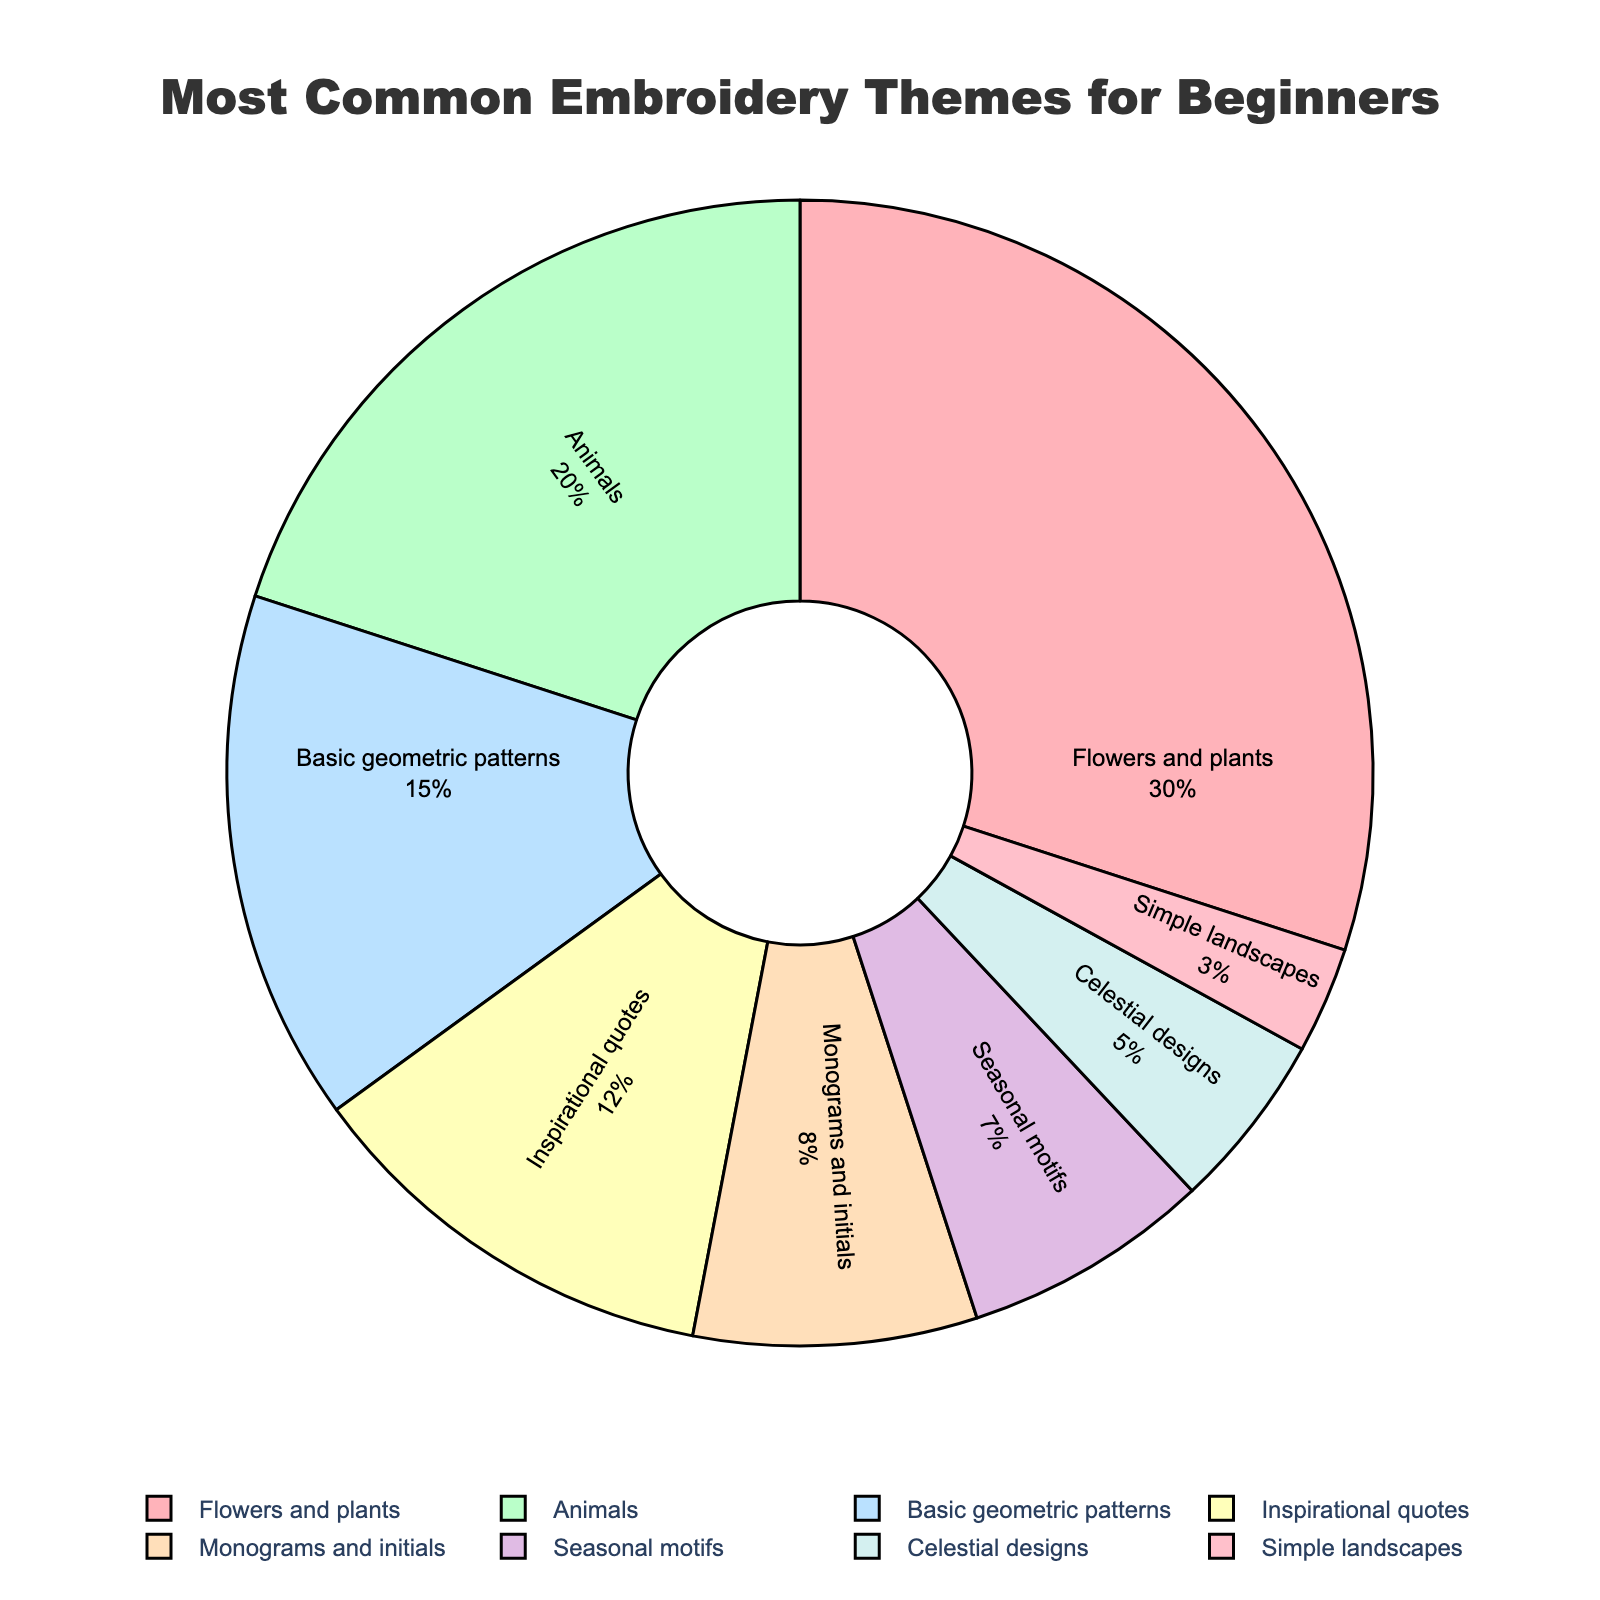Which theme is the most popular among beginners according to the pie chart? The largest segment in the pie chart represents the theme "Flowers and plants," which takes up 30% of the total.
Answer: Flowers and plants How do the percentages of animals and basic geometric patterns compare? The segment for animals is 20%, and the segment for basic geometric patterns is 15%. Comparing these values, animals have a higher percentage than basic geometric patterns.
Answer: Animals What is the combined percentage of inspirational quotes, monograms and initials, and seasonal motifs? Inspirational quotes: 12%, Monograms and initials: 8%, Seasonal motifs: 7%. Adding these together, 12% + 8% + 7% = 27%.
Answer: 27% Which theme has the smallest representation in the pie chart? The smallest segment in the pie chart is for "Simple landscapes," which has a percentage of 3%.
Answer: Simple landscapes How much larger in percentage is the representation of flowers and plants compared to celestial designs? The flowers and plants segment has 30%, and celestial designs have 5%. The difference is 30% - 5% = 25%.
Answer: 25% If you were to combine the percentages for simple landscapes and seasonal motifs, would this new segment be larger than the monograms and initials segment? Simple landscapes: 3%, Seasonal motifs: 7%. Combined percentage is 3% + 7% = 10%. Monograms and initials is 8%. 10% is larger than 8%.
Answer: Yes What percentage of embroidery themes falls under the "miscellaneous" category, grouping themes with less than 10% representation together (seasonal motifs, celestial designs, simple landscapes)? Seasonal motifs: 7%, Celestial designs: 5%, Simple landscapes: 3%. Adding these, 7% + 5% + 3% = 15%.
Answer: 15% Which two themes together make up one-third of the total percentages? One-third of 100% is approximately 33.33%. The percentages of flowers and plants (30%) and simple landscapes (3%) add up to 33%. These are the two themes that together make up about one-third of the total.
Answer: Flowers and plants and simple landscapes 